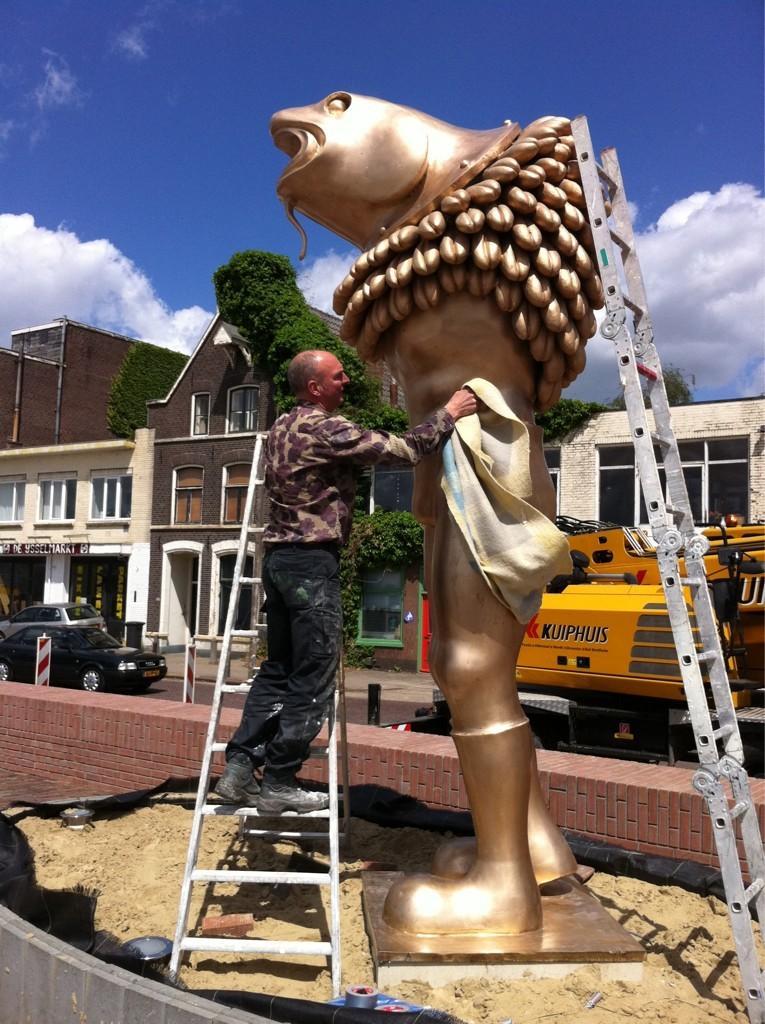Please provide a concise description of this image. In this picture we can see a statue and on the left side of the statue we can see a man is standing on the ladder and on the right side of the statue there is another ladder. Behind the statue there are some vehicles on the road, buildings, trees and a sky. 